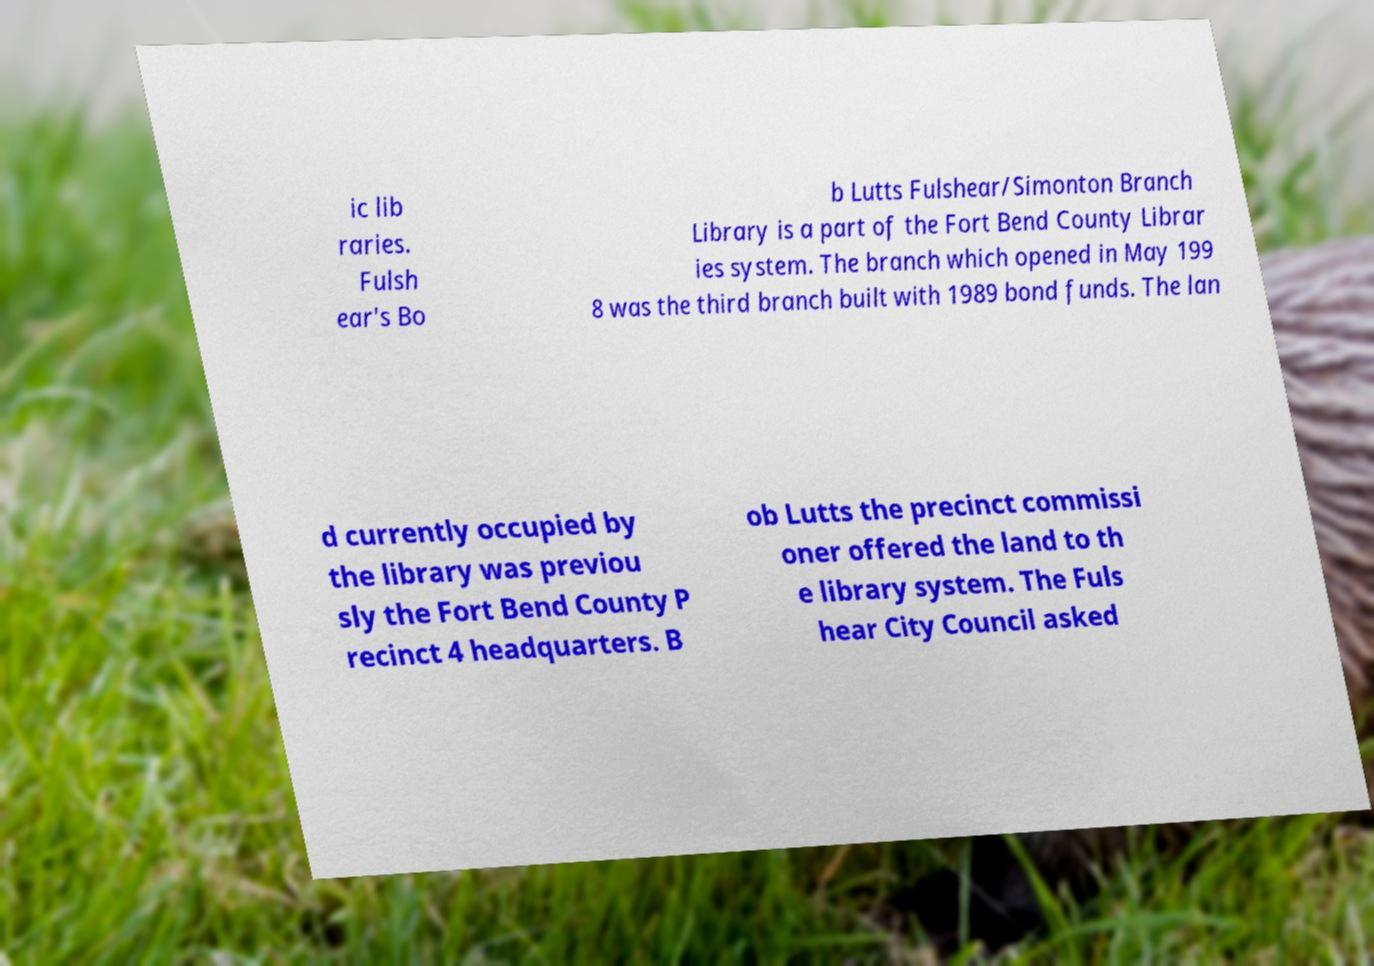Could you assist in decoding the text presented in this image and type it out clearly? ic lib raries. Fulsh ear's Bo b Lutts Fulshear/Simonton Branch Library is a part of the Fort Bend County Librar ies system. The branch which opened in May 199 8 was the third branch built with 1989 bond funds. The lan d currently occupied by the library was previou sly the Fort Bend County P recinct 4 headquarters. B ob Lutts the precinct commissi oner offered the land to th e library system. The Fuls hear City Council asked 